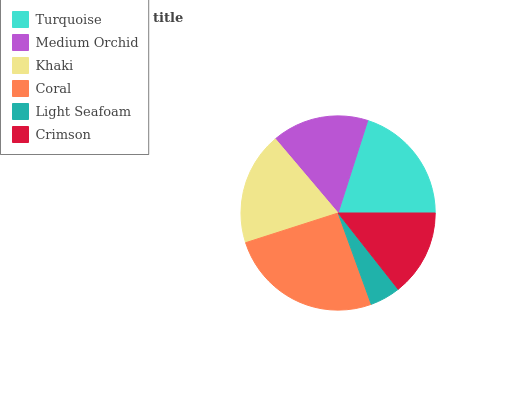Is Light Seafoam the minimum?
Answer yes or no. Yes. Is Coral the maximum?
Answer yes or no. Yes. Is Medium Orchid the minimum?
Answer yes or no. No. Is Medium Orchid the maximum?
Answer yes or no. No. Is Turquoise greater than Medium Orchid?
Answer yes or no. Yes. Is Medium Orchid less than Turquoise?
Answer yes or no. Yes. Is Medium Orchid greater than Turquoise?
Answer yes or no. No. Is Turquoise less than Medium Orchid?
Answer yes or no. No. Is Khaki the high median?
Answer yes or no. Yes. Is Medium Orchid the low median?
Answer yes or no. Yes. Is Medium Orchid the high median?
Answer yes or no. No. Is Turquoise the low median?
Answer yes or no. No. 